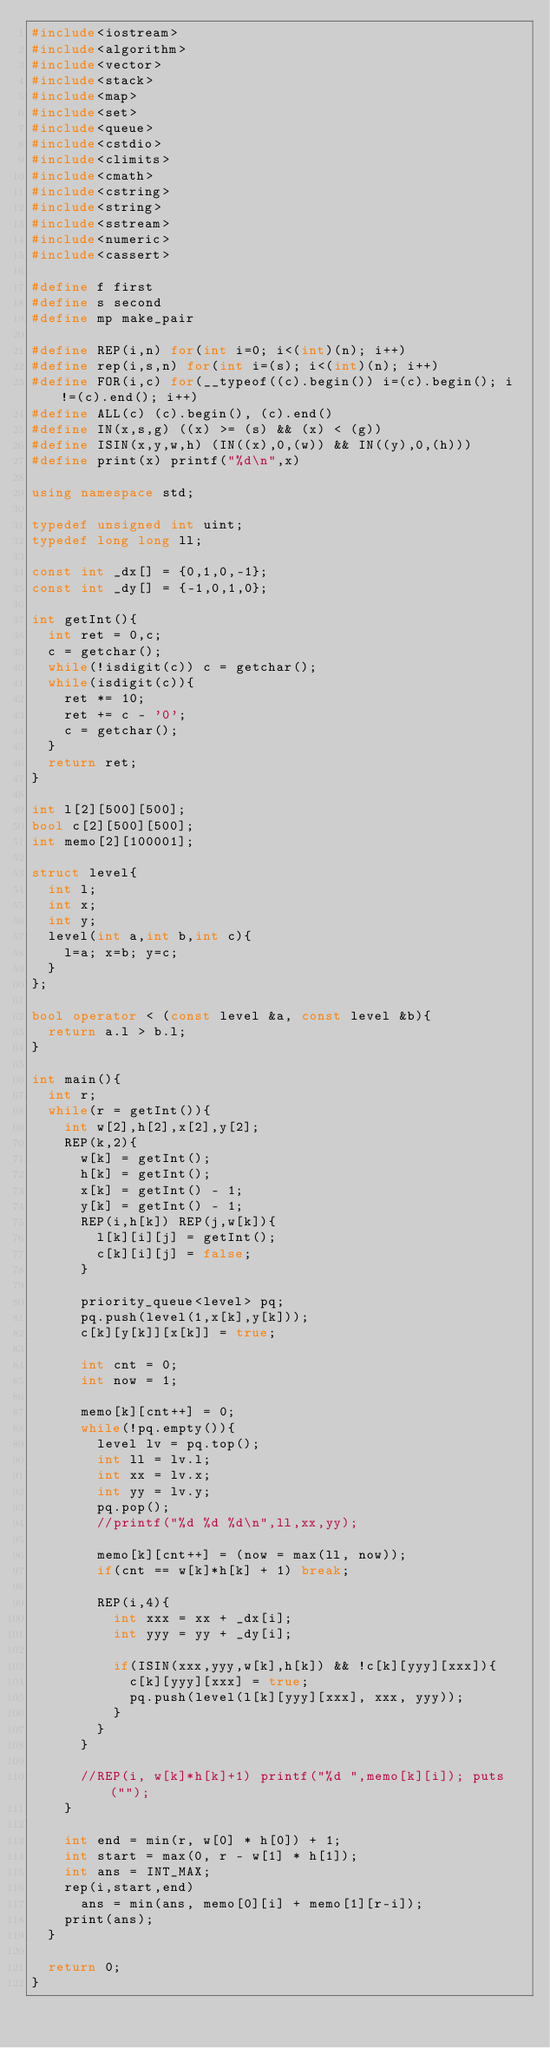<code> <loc_0><loc_0><loc_500><loc_500><_C++_>#include<iostream>
#include<algorithm>
#include<vector>
#include<stack>
#include<map>
#include<set>
#include<queue>
#include<cstdio>
#include<climits>
#include<cmath>
#include<cstring>
#include<string>
#include<sstream>
#include<numeric>
#include<cassert>

#define f first
#define s second
#define mp make_pair

#define REP(i,n) for(int i=0; i<(int)(n); i++)
#define rep(i,s,n) for(int i=(s); i<(int)(n); i++)
#define FOR(i,c) for(__typeof((c).begin()) i=(c).begin(); i!=(c).end(); i++)
#define ALL(c) (c).begin(), (c).end()
#define IN(x,s,g) ((x) >= (s) && (x) < (g))
#define ISIN(x,y,w,h) (IN((x),0,(w)) && IN((y),0,(h)))
#define print(x) printf("%d\n",x)

using namespace std;

typedef unsigned int uint;
typedef long long ll;

const int _dx[] = {0,1,0,-1};
const int _dy[] = {-1,0,1,0};

int getInt(){
  int ret = 0,c;
  c = getchar();
  while(!isdigit(c)) c = getchar();
  while(isdigit(c)){
    ret *= 10;
    ret += c - '0';
    c = getchar();
  }
  return ret;
}

int l[2][500][500];
bool c[2][500][500];
int memo[2][100001];

struct level{
  int l;
  int x;
  int y;
  level(int a,int b,int c){
    l=a; x=b; y=c;
  }
};

bool operator < (const level &a, const level &b){
  return a.l > b.l;
}

int main(){
  int r;
  while(r = getInt()){
    int w[2],h[2],x[2],y[2];
    REP(k,2){
      w[k] = getInt();
      h[k] = getInt();
      x[k] = getInt() - 1;
      y[k] = getInt() - 1;
      REP(i,h[k]) REP(j,w[k]){
        l[k][i][j] = getInt();
        c[k][i][j] = false;
      }

      priority_queue<level> pq;
      pq.push(level(1,x[k],y[k]));
      c[k][y[k]][x[k]] = true;

      int cnt = 0;
      int now = 1;

      memo[k][cnt++] = 0;
      while(!pq.empty()){
        level lv = pq.top();
        int ll = lv.l;
        int xx = lv.x;
        int yy = lv.y;
        pq.pop();
        //printf("%d %d %d\n",ll,xx,yy);

        memo[k][cnt++] = (now = max(ll, now));
        if(cnt == w[k]*h[k] + 1) break;

        REP(i,4){
          int xxx = xx + _dx[i];
          int yyy = yy + _dy[i];

          if(ISIN(xxx,yyy,w[k],h[k]) && !c[k][yyy][xxx]){
            c[k][yyy][xxx] = true;
            pq.push(level(l[k][yyy][xxx], xxx, yyy));
          }
        }
      }

      //REP(i, w[k]*h[k]+1) printf("%d ",memo[k][i]); puts("");
    }

    int end = min(r, w[0] * h[0]) + 1;
    int start = max(0, r - w[1] * h[1]);
    int ans = INT_MAX;
    rep(i,start,end)
      ans = min(ans, memo[0][i] + memo[1][r-i]);
    print(ans);
  }

  return 0;
}</code> 